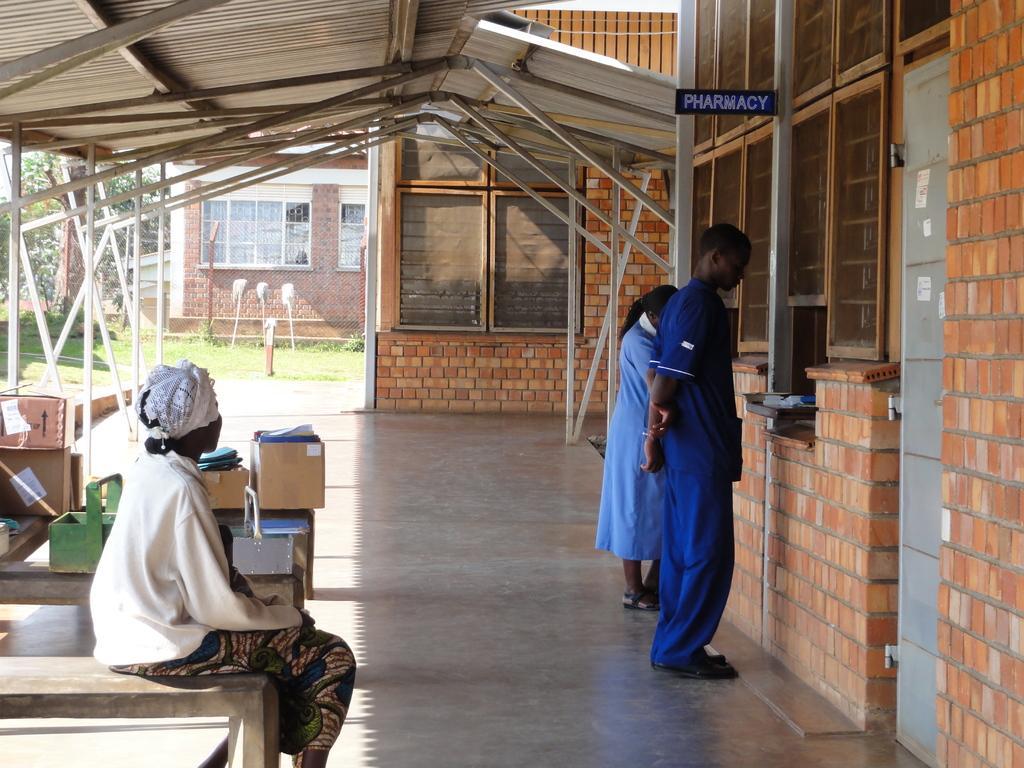How would you summarize this image in a sentence or two? On the left we can see one woman sitting on the bench. On the right we can see two persons were standing. In the background there is a brick wall,window,boxes,table,trees and grass. 